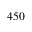Convert formula to latex. <formula><loc_0><loc_0><loc_500><loc_500>4 5 0</formula> 